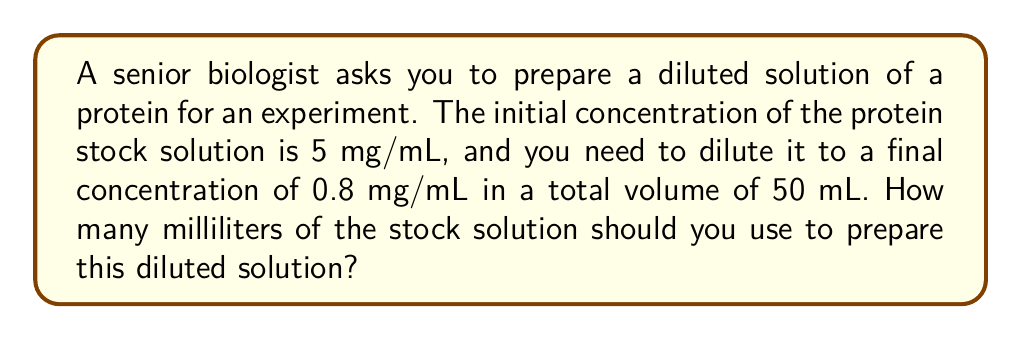Solve this math problem. To solve this problem, we can use the dilution equation:

$$ C_1V_1 = C_2V_2 $$

Where:
$C_1$ = Initial concentration (5 mg/mL)
$V_1$ = Volume of stock solution to be used (unknown)
$C_2$ = Final concentration (0.8 mg/mL)
$V_2$ = Total volume of diluted solution (50 mL)

Let's plug in the known values:

$$ 5 \cdot V_1 = 0.8 \cdot 50 $$

Now, we can solve for $V_1$:

$$ 5V_1 = 40 $$
$$ V_1 = \frac{40}{5} = 8 $$

Therefore, you need to use 8 mL of the stock solution.

To verify:
1. 8 mL of stock solution contains: $8 \text{ mL} \cdot 5 \text{ mg/mL} = 40 \text{ mg}$ of protein
2. This amount in 50 mL gives a concentration of: $\frac{40 \text{ mg}}{50 \text{ mL}} = 0.8 \text{ mg/mL}$

This confirms our calculation is correct.
Answer: 8 mL 